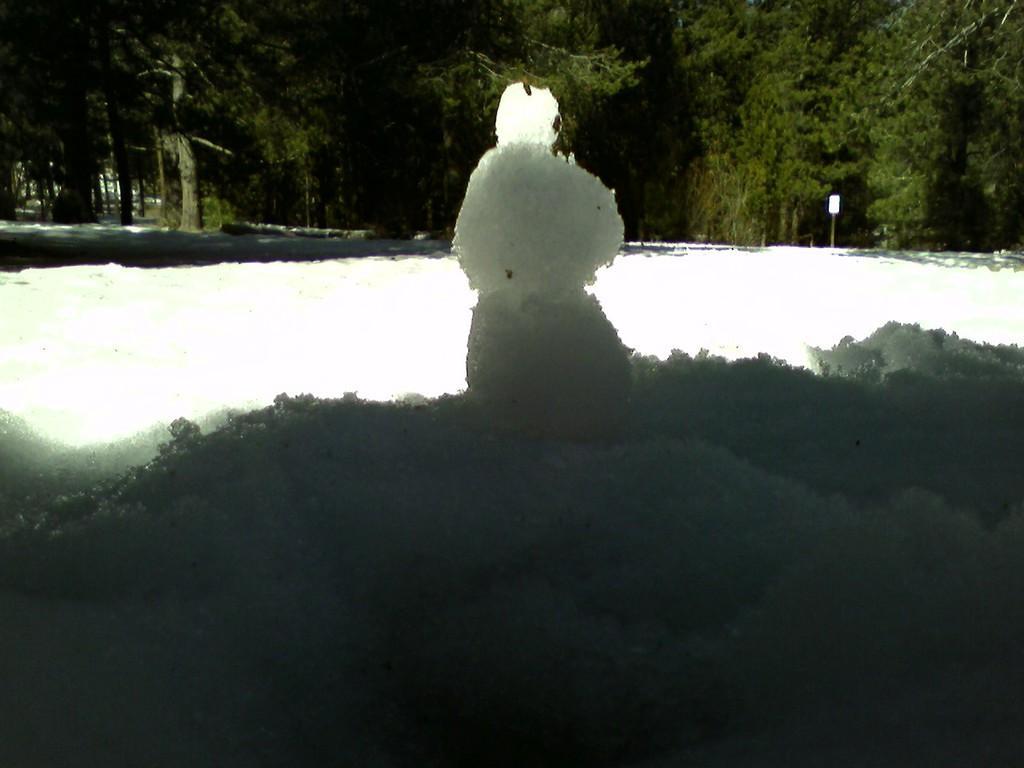Describe this image in one or two sentences. This picture contains a snowman. At the bottom of the picture, we see snow. There are trees in the background and we see a white color board. 